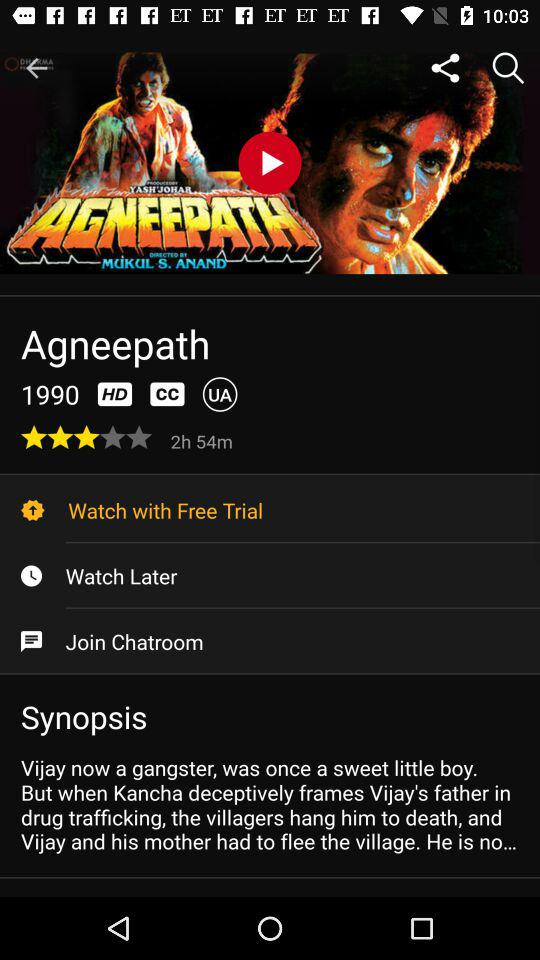What is the name of the movie? The movie name is "Agneepath". 